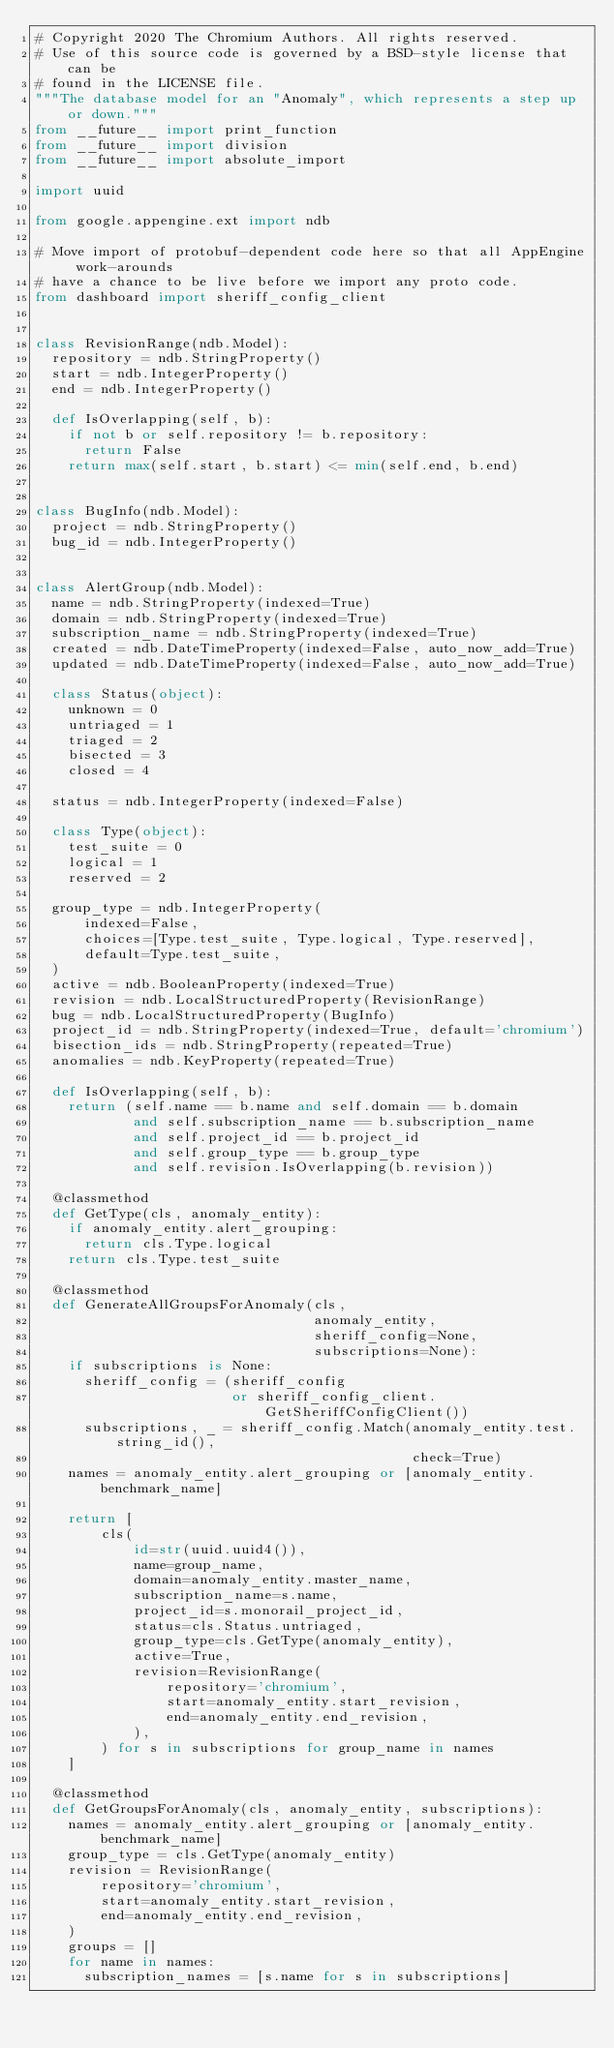<code> <loc_0><loc_0><loc_500><loc_500><_Python_># Copyright 2020 The Chromium Authors. All rights reserved.
# Use of this source code is governed by a BSD-style license that can be
# found in the LICENSE file.
"""The database model for an "Anomaly", which represents a step up or down."""
from __future__ import print_function
from __future__ import division
from __future__ import absolute_import

import uuid

from google.appengine.ext import ndb

# Move import of protobuf-dependent code here so that all AppEngine work-arounds
# have a chance to be live before we import any proto code.
from dashboard import sheriff_config_client


class RevisionRange(ndb.Model):
  repository = ndb.StringProperty()
  start = ndb.IntegerProperty()
  end = ndb.IntegerProperty()

  def IsOverlapping(self, b):
    if not b or self.repository != b.repository:
      return False
    return max(self.start, b.start) <= min(self.end, b.end)


class BugInfo(ndb.Model):
  project = ndb.StringProperty()
  bug_id = ndb.IntegerProperty()


class AlertGroup(ndb.Model):
  name = ndb.StringProperty(indexed=True)
  domain = ndb.StringProperty(indexed=True)
  subscription_name = ndb.StringProperty(indexed=True)
  created = ndb.DateTimeProperty(indexed=False, auto_now_add=True)
  updated = ndb.DateTimeProperty(indexed=False, auto_now_add=True)

  class Status(object):
    unknown = 0
    untriaged = 1
    triaged = 2
    bisected = 3
    closed = 4

  status = ndb.IntegerProperty(indexed=False)

  class Type(object):
    test_suite = 0
    logical = 1
    reserved = 2

  group_type = ndb.IntegerProperty(
      indexed=False,
      choices=[Type.test_suite, Type.logical, Type.reserved],
      default=Type.test_suite,
  )
  active = ndb.BooleanProperty(indexed=True)
  revision = ndb.LocalStructuredProperty(RevisionRange)
  bug = ndb.LocalStructuredProperty(BugInfo)
  project_id = ndb.StringProperty(indexed=True, default='chromium')
  bisection_ids = ndb.StringProperty(repeated=True)
  anomalies = ndb.KeyProperty(repeated=True)

  def IsOverlapping(self, b):
    return (self.name == b.name and self.domain == b.domain
            and self.subscription_name == b.subscription_name
            and self.project_id == b.project_id
            and self.group_type == b.group_type
            and self.revision.IsOverlapping(b.revision))

  @classmethod
  def GetType(cls, anomaly_entity):
    if anomaly_entity.alert_grouping:
      return cls.Type.logical
    return cls.Type.test_suite

  @classmethod
  def GenerateAllGroupsForAnomaly(cls,
                                  anomaly_entity,
                                  sheriff_config=None,
                                  subscriptions=None):
    if subscriptions is None:
      sheriff_config = (sheriff_config
                        or sheriff_config_client.GetSheriffConfigClient())
      subscriptions, _ = sheriff_config.Match(anomaly_entity.test.string_id(),
                                              check=True)
    names = anomaly_entity.alert_grouping or [anomaly_entity.benchmark_name]

    return [
        cls(
            id=str(uuid.uuid4()),
            name=group_name,
            domain=anomaly_entity.master_name,
            subscription_name=s.name,
            project_id=s.monorail_project_id,
            status=cls.Status.untriaged,
            group_type=cls.GetType(anomaly_entity),
            active=True,
            revision=RevisionRange(
                repository='chromium',
                start=anomaly_entity.start_revision,
                end=anomaly_entity.end_revision,
            ),
        ) for s in subscriptions for group_name in names
    ]

  @classmethod
  def GetGroupsForAnomaly(cls, anomaly_entity, subscriptions):
    names = anomaly_entity.alert_grouping or [anomaly_entity.benchmark_name]
    group_type = cls.GetType(anomaly_entity)
    revision = RevisionRange(
        repository='chromium',
        start=anomaly_entity.start_revision,
        end=anomaly_entity.end_revision,
    )
    groups = []
    for name in names:
      subscription_names = [s.name for s in subscriptions]</code> 